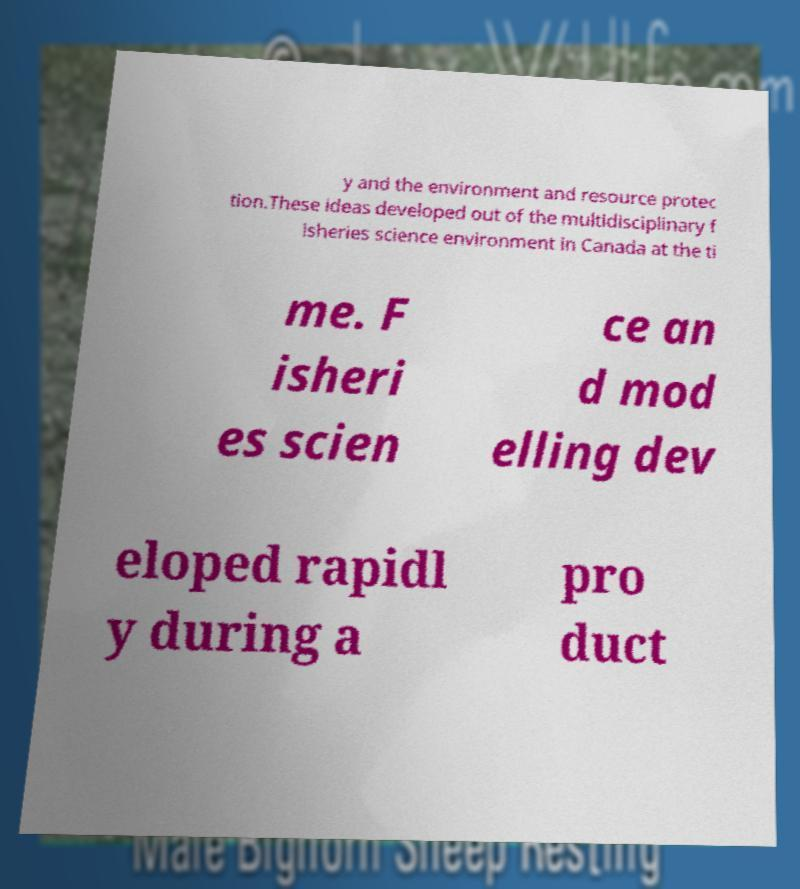There's text embedded in this image that I need extracted. Can you transcribe it verbatim? y and the environment and resource protec tion.These ideas developed out of the multidisciplinary f isheries science environment in Canada at the ti me. F isheri es scien ce an d mod elling dev eloped rapidl y during a pro duct 